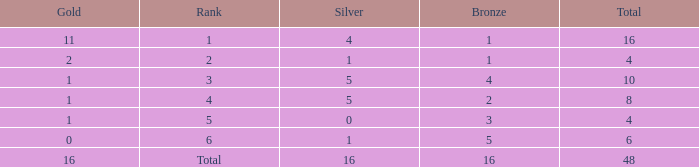How many total gold are less than 4? 0.0. 